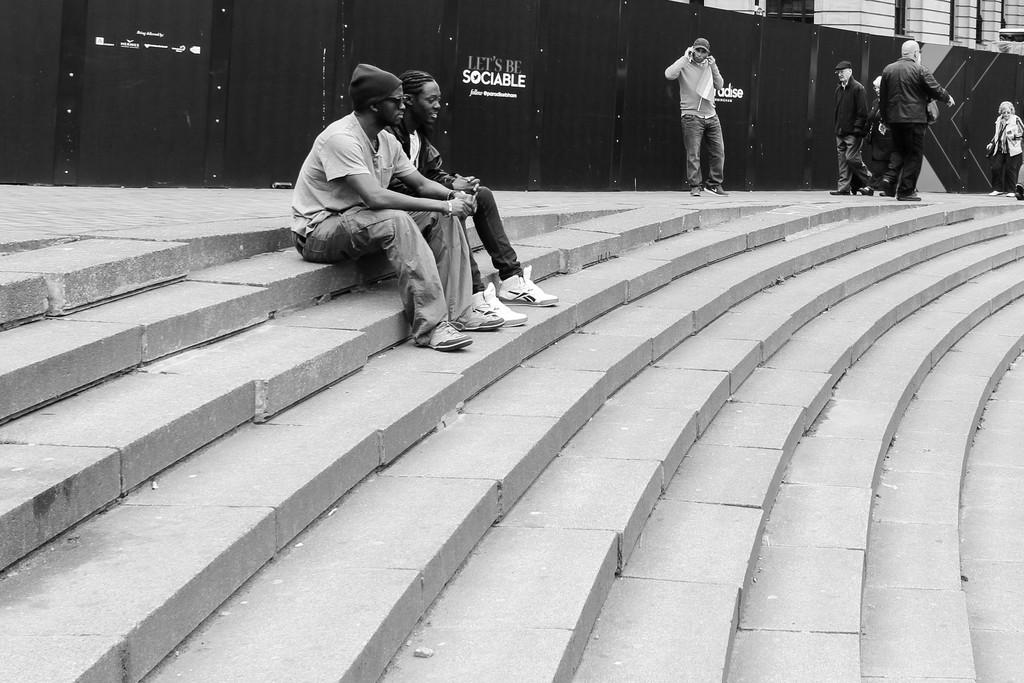What is the color scheme of the image? The image is black and white. What architectural feature can be seen in the image? There are steps in the image. Who or what is present in the image? There are people in the image. What can be used for walking or traveling in the image? There is a walk or path in the image. What else can be seen in the image besides the people and steps? There are objects in the image. What type of animal is reciting a verse while wearing a suit in the image? There is no animal, verse, or suit present in the image. 